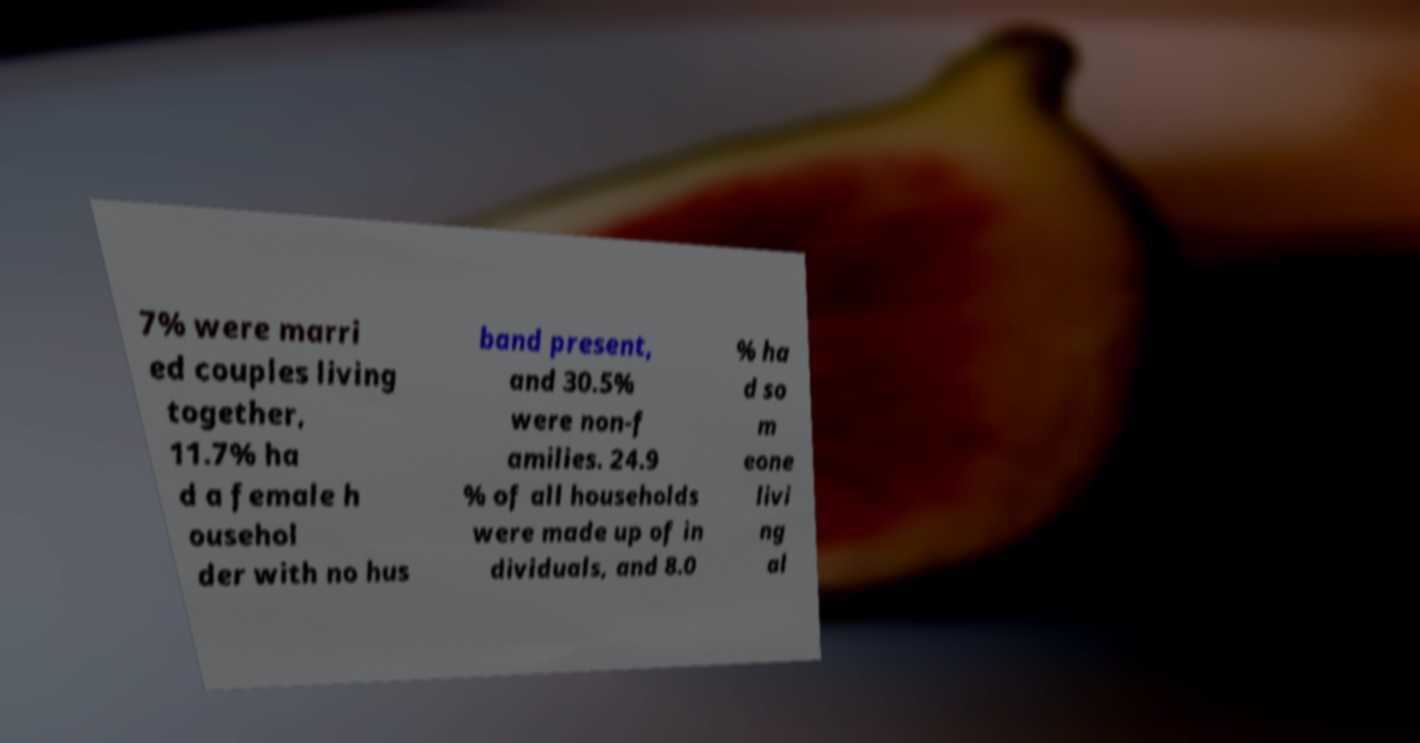Could you extract and type out the text from this image? 7% were marri ed couples living together, 11.7% ha d a female h ousehol der with no hus band present, and 30.5% were non-f amilies. 24.9 % of all households were made up of in dividuals, and 8.0 % ha d so m eone livi ng al 